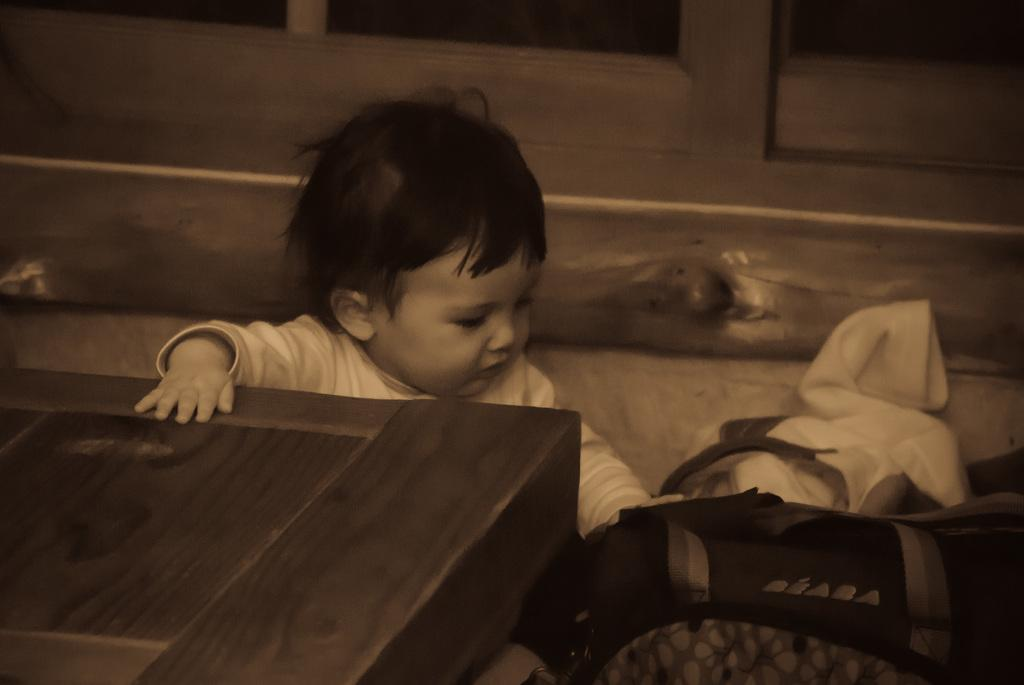What is the position of the kid in the image? The kid is sitting on the floor in the image. What is the kid touching in the image? The kid's hand is on the table in the image. What object can be seen in the image that might be used for carrying items? There is a bag in the image. What type of items are visible in the image? There are clothes in the image. What architectural feature can be seen in the background of the image? There is a door in the background of the image. What type of mitten is the kid wearing in the image? There is no mitten visible in the image; the kid's hand is on the table. What date is marked on the calendar in the image? There is no calendar present in the image. 